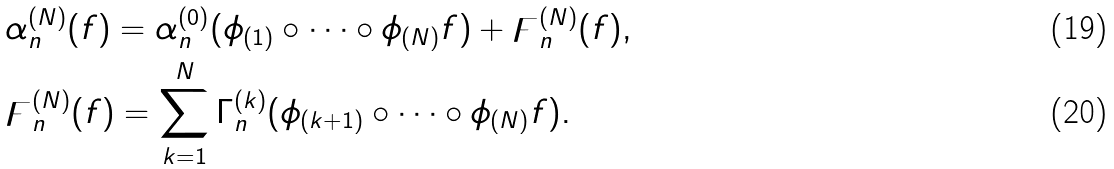Convert formula to latex. <formula><loc_0><loc_0><loc_500><loc_500>& \alpha _ { n } ^ { ( N ) } ( f ) = \alpha _ { n } ^ { ( 0 ) } ( \phi _ { ( 1 ) } \circ \dots \circ \phi _ { ( N ) } f ) + \digamma _ { n } ^ { ( N ) } ( f ) , \\ & \digamma _ { n } ^ { ( N ) } ( f ) = \sum _ { k = 1 } ^ { N } \Gamma _ { n } ^ { ( k ) } ( \phi _ { ( k + 1 ) } \circ \dots \circ \phi _ { ( N ) } f ) .</formula> 